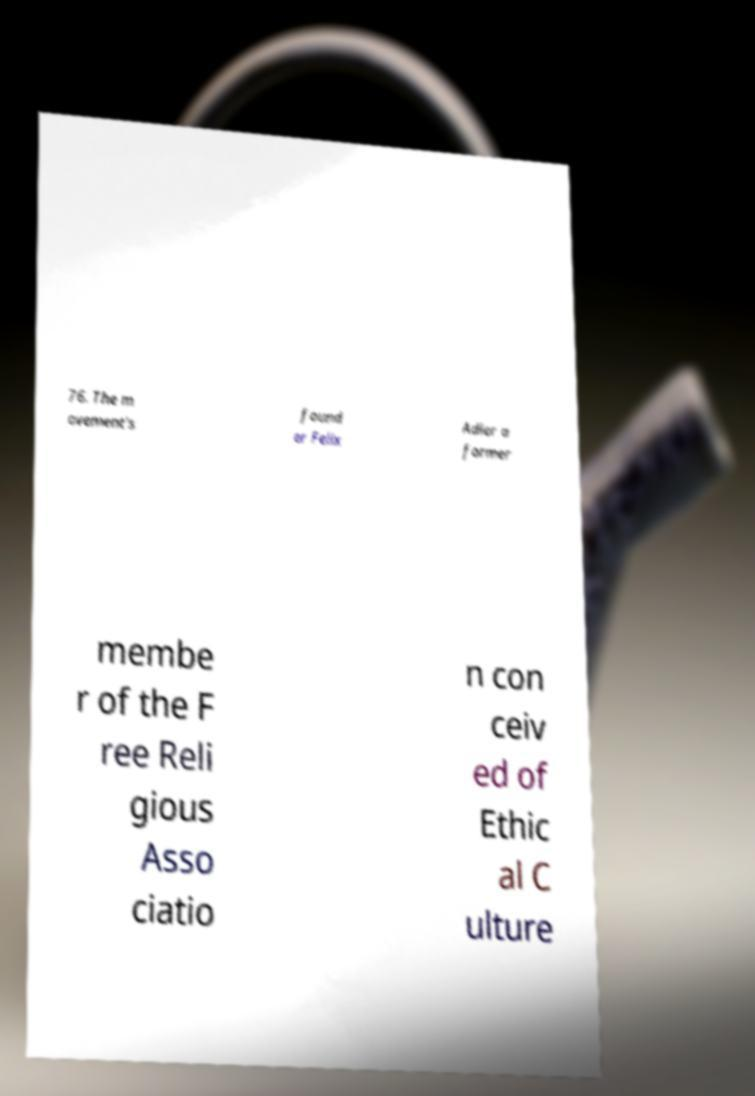Can you read and provide the text displayed in the image?This photo seems to have some interesting text. Can you extract and type it out for me? 76. The m ovement's found er Felix Adler a former membe r of the F ree Reli gious Asso ciatio n con ceiv ed of Ethic al C ulture 